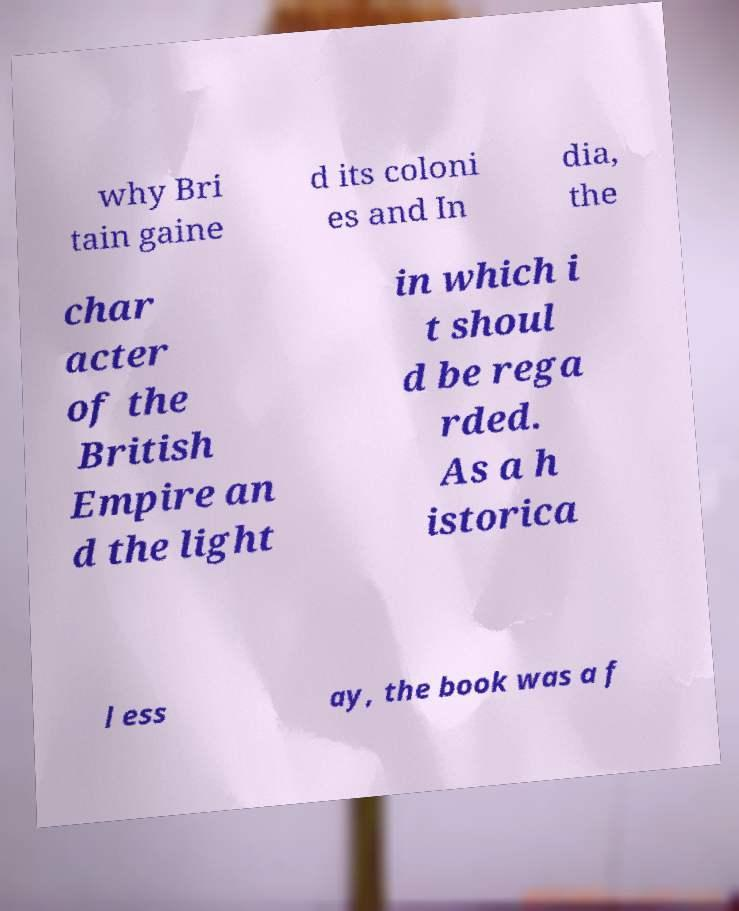Can you read and provide the text displayed in the image?This photo seems to have some interesting text. Can you extract and type it out for me? why Bri tain gaine d its coloni es and In dia, the char acter of the British Empire an d the light in which i t shoul d be rega rded. As a h istorica l ess ay, the book was a f 